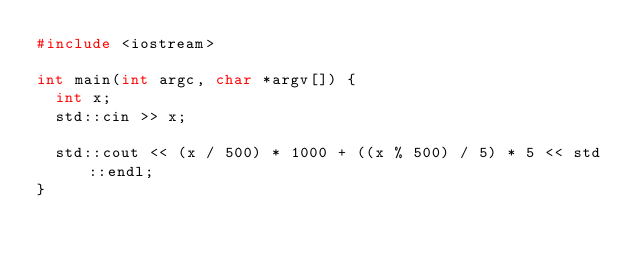Convert code to text. <code><loc_0><loc_0><loc_500><loc_500><_C++_>#include <iostream>

int main(int argc, char *argv[]) {
  int x;
  std::cin >> x;

  std::cout << (x / 500) * 1000 + ((x % 500) / 5) * 5 << std::endl;
}
</code> 